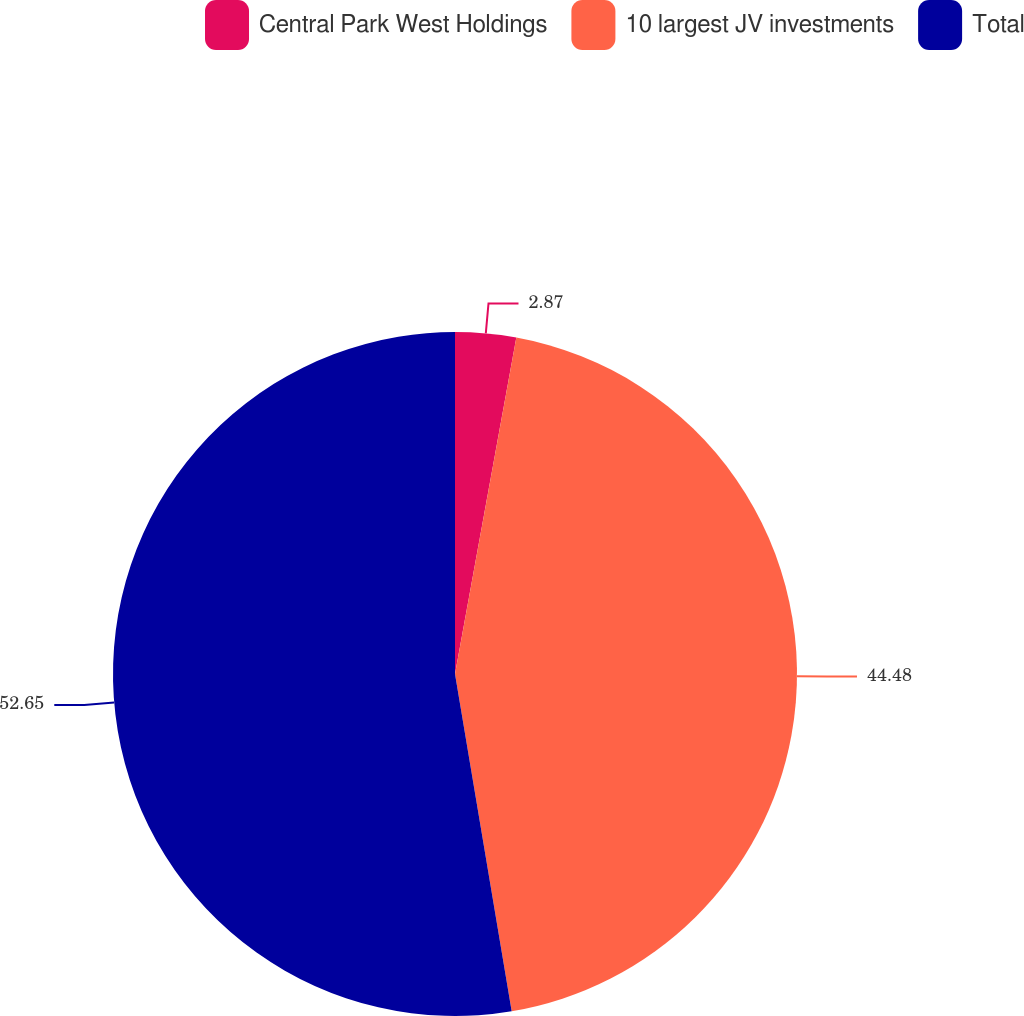Convert chart to OTSL. <chart><loc_0><loc_0><loc_500><loc_500><pie_chart><fcel>Central Park West Holdings<fcel>10 largest JV investments<fcel>Total<nl><fcel>2.87%<fcel>44.48%<fcel>52.65%<nl></chart> 